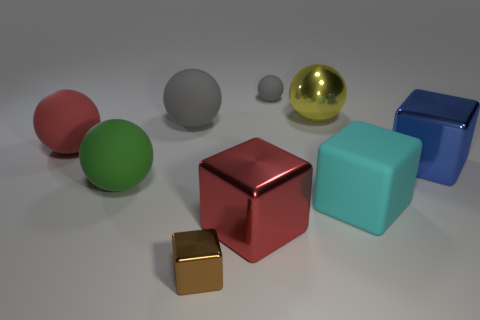Subtract 2 spheres. How many spheres are left? 3 Subtract all red balls. How many balls are left? 4 Subtract all red spheres. How many spheres are left? 4 Subtract all blue balls. Subtract all gray cubes. How many balls are left? 5 Subtract all blocks. How many objects are left? 5 Subtract 0 purple blocks. How many objects are left? 9 Subtract all red rubber spheres. Subtract all big red metal cubes. How many objects are left? 7 Add 1 big red spheres. How many big red spheres are left? 2 Add 5 large blue shiny things. How many large blue shiny things exist? 6 